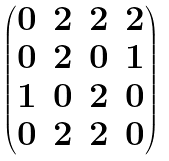Convert formula to latex. <formula><loc_0><loc_0><loc_500><loc_500>\begin{pmatrix} 0 & 2 & 2 & 2 \\ 0 & 2 & 0 & 1 \\ 1 & 0 & 2 & 0 \\ 0 & 2 & 2 & 0 \end{pmatrix}</formula> 